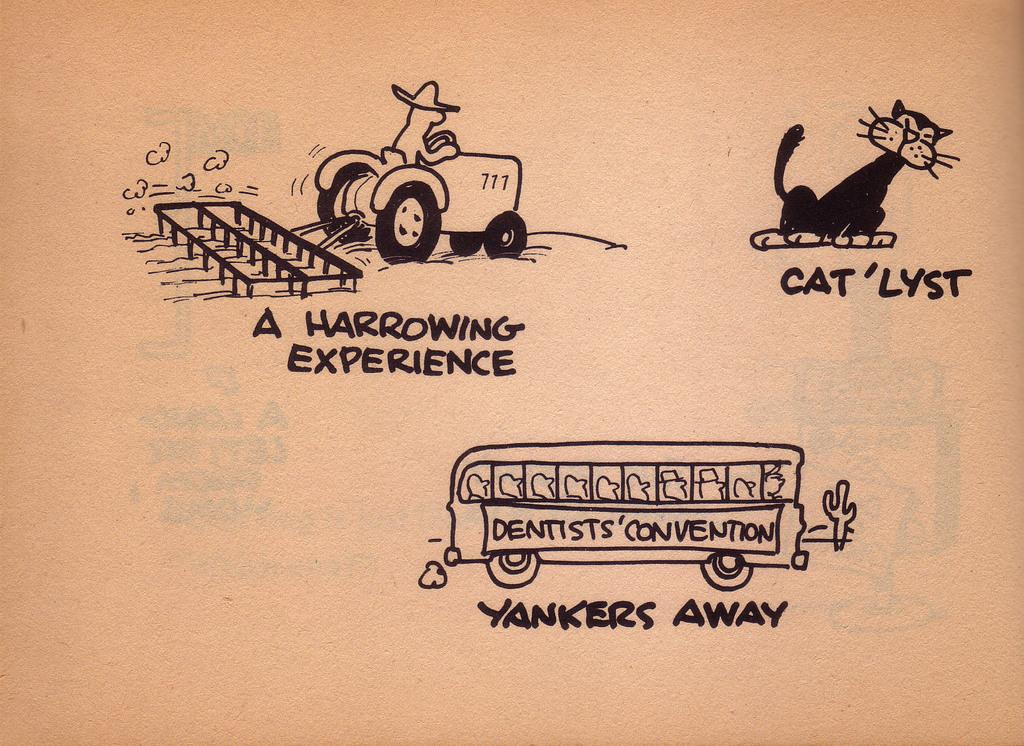What is depicted on the paper in the image? The paper contains cartoon toys. What is the object in front of the paper? There is a bus in front of the paper. Is there any text on the paper? Yes, there is writing on the paper. Can you see a river in the background of the image? There is no river visible in the image. Is there a cat playing with the cartoon toys on the paper? There is no cat present in the image. 